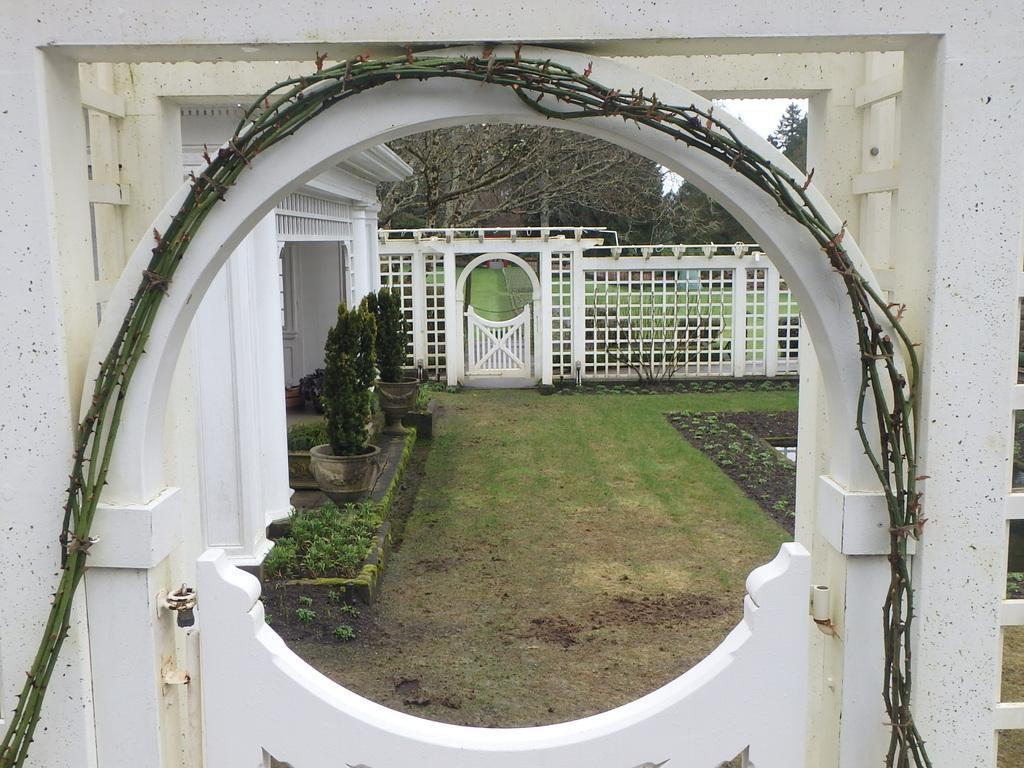In one or two sentences, can you explain what this image depicts? This image is taken outside. There is a gate having few creepers attached to it. Behind the gate there is grassland having few pots with plants. Few plants are on the land. Behind it there is a fence having a gate. Top of image there are few trees and sky. 